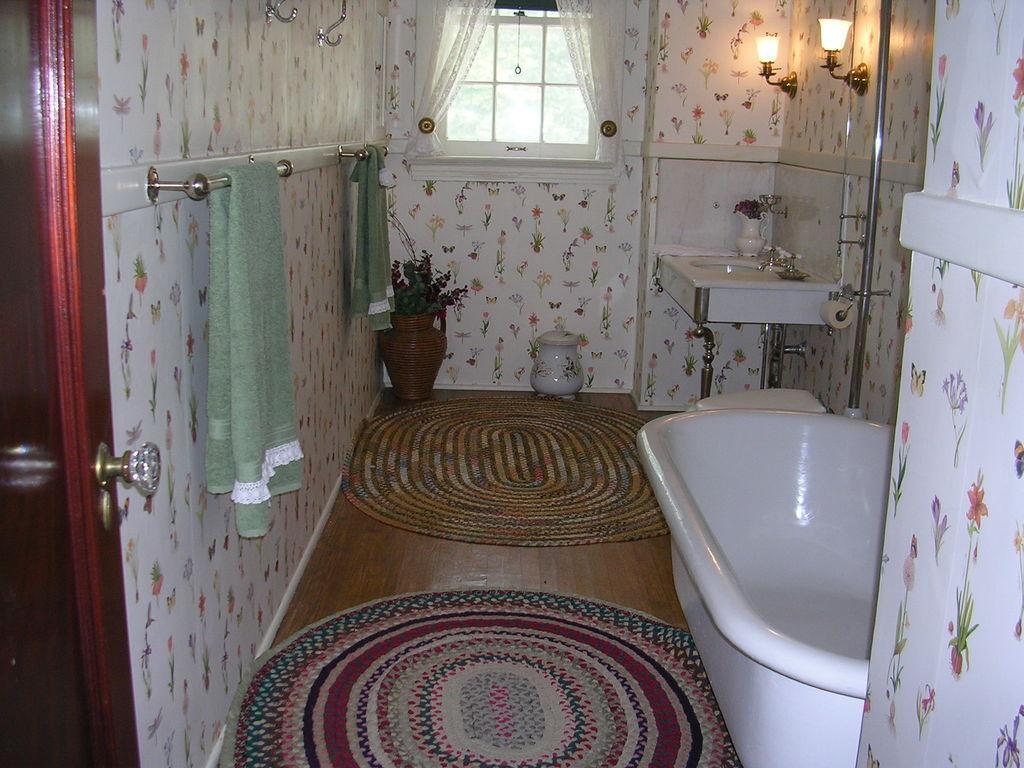In one or two sentences, can you explain what this image depicts? The image is taken in the bathroom. On the right side of the image there is a bathtub and a sink. On the left there are towels on the hanger. At the bottom we can see floor mats and a plant. In the background there is a window, lights and a wall. 